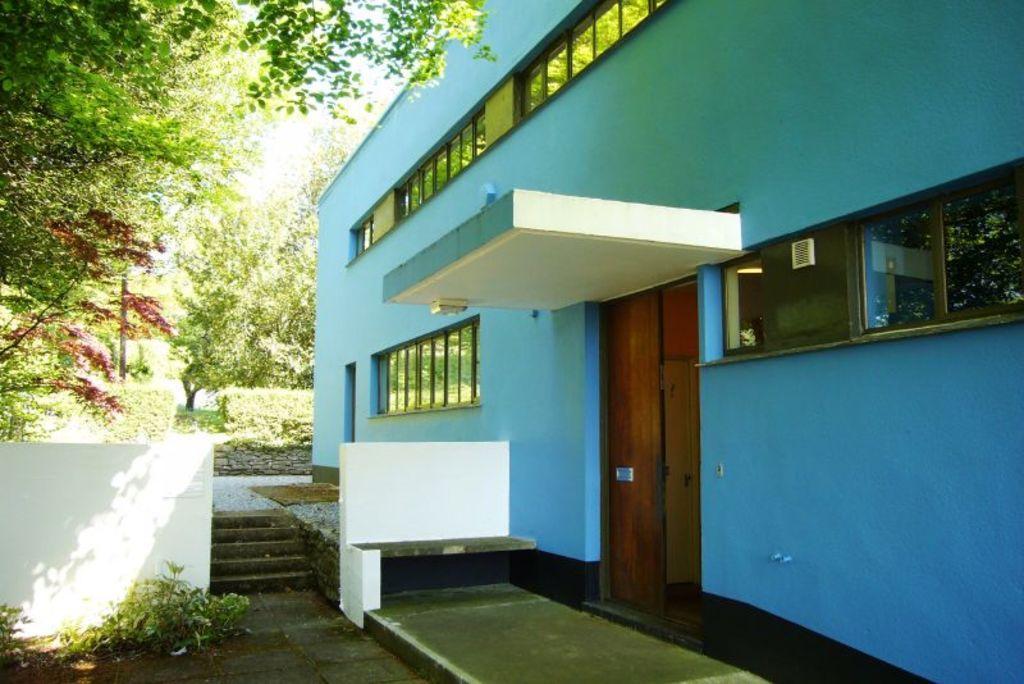In one or two sentences, can you explain what this image depicts? In this picture we can see a building with windows, doors, stairs, wall and in the background we can see trees. 